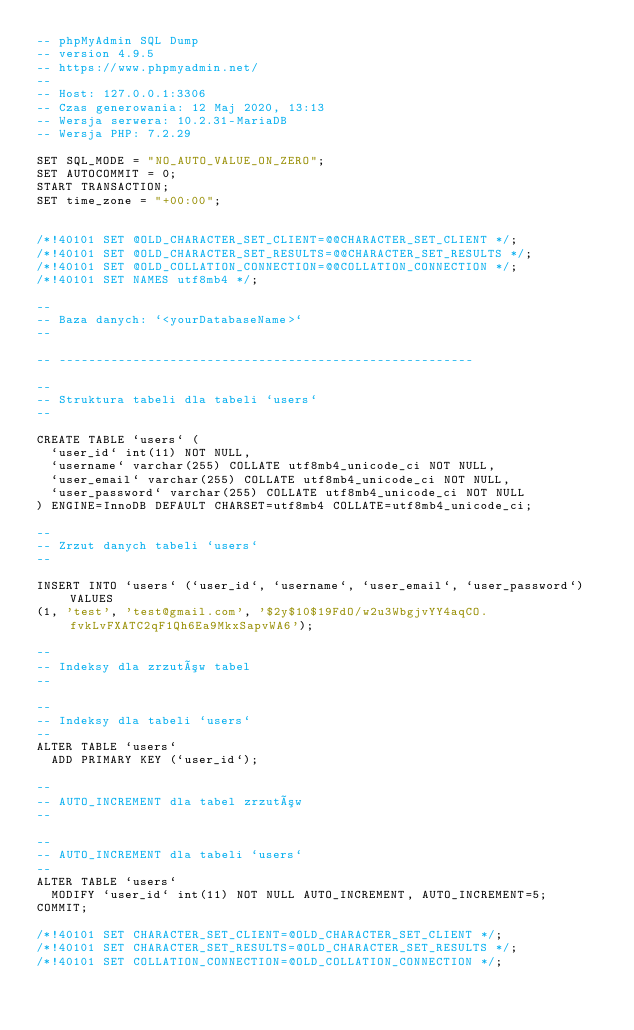<code> <loc_0><loc_0><loc_500><loc_500><_SQL_>-- phpMyAdmin SQL Dump
-- version 4.9.5
-- https://www.phpmyadmin.net/
--
-- Host: 127.0.0.1:3306
-- Czas generowania: 12 Maj 2020, 13:13
-- Wersja serwera: 10.2.31-MariaDB
-- Wersja PHP: 7.2.29

SET SQL_MODE = "NO_AUTO_VALUE_ON_ZERO";
SET AUTOCOMMIT = 0;
START TRANSACTION;
SET time_zone = "+00:00";


/*!40101 SET @OLD_CHARACTER_SET_CLIENT=@@CHARACTER_SET_CLIENT */;
/*!40101 SET @OLD_CHARACTER_SET_RESULTS=@@CHARACTER_SET_RESULTS */;
/*!40101 SET @OLD_COLLATION_CONNECTION=@@COLLATION_CONNECTION */;
/*!40101 SET NAMES utf8mb4 */;

--
-- Baza danych: `<yourDatabaseName>`
--

-- --------------------------------------------------------

--
-- Struktura tabeli dla tabeli `users`
--

CREATE TABLE `users` (
  `user_id` int(11) NOT NULL,
  `username` varchar(255) COLLATE utf8mb4_unicode_ci NOT NULL,
  `user_email` varchar(255) COLLATE utf8mb4_unicode_ci NOT NULL,
  `user_password` varchar(255) COLLATE utf8mb4_unicode_ci NOT NULL
) ENGINE=InnoDB DEFAULT CHARSET=utf8mb4 COLLATE=utf8mb4_unicode_ci;

--
-- Zrzut danych tabeli `users`
--

INSERT INTO `users` (`user_id`, `username`, `user_email`, `user_password`) VALUES
(1, 'test', 'test@gmail.com', '$2y$10$19FdO/w2u3WbgjvYY4aqCO.fvkLvFXATC2qF1Qh6Ea9MkxSapvWA6');

--
-- Indeksy dla zrzutów tabel
--

--
-- Indeksy dla tabeli `users`
--
ALTER TABLE `users`
  ADD PRIMARY KEY (`user_id`);

--
-- AUTO_INCREMENT dla tabel zrzutów
--

--
-- AUTO_INCREMENT dla tabeli `users`
--
ALTER TABLE `users`
  MODIFY `user_id` int(11) NOT NULL AUTO_INCREMENT, AUTO_INCREMENT=5;
COMMIT;

/*!40101 SET CHARACTER_SET_CLIENT=@OLD_CHARACTER_SET_CLIENT */;
/*!40101 SET CHARACTER_SET_RESULTS=@OLD_CHARACTER_SET_RESULTS */;
/*!40101 SET COLLATION_CONNECTION=@OLD_COLLATION_CONNECTION */;
</code> 